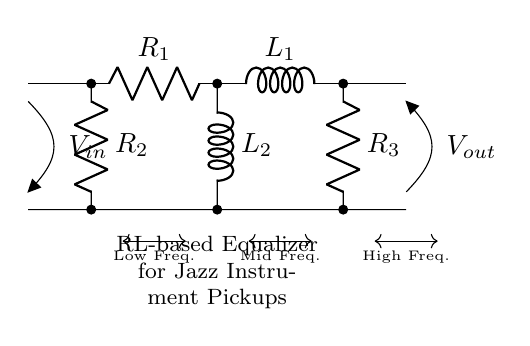What is the input voltage in this circuit? The input voltage is represented by V in the diagram, which is shown at the left side of the circuit. It is indicated as an open terminal labeled V in.
Answer: V in How many resistors are present in the circuit? The diagram shows three resistors designated as R one, R two, and R three, each labeled along the circuit. They are clearly identified by their respective symbols and labels.
Answer: 3 What type of inductors are used in this circuit? There are two inductors labeled as L one and L two in the diagram. Their labels indicate they are inductors, and they are connected in series with other components in the path of current.
Answer: 2 What is the function of the resistors in this circuit? The resistors are used to shape the frequency response of the circuit. In an RL-based circuit, resistors work together with inductors to control the gain and attenuation of different frequency ranges.
Answer: Shaping frequency response Which part of the circuit represents the low-frequency response? The section that includes R one and L one is designated for low frequency and is marked in the diagram below the circuit. This segment is the first in the chain, showing it processes lower frequencies primarily.
Answer: R one and L one What is the purpose of the labeled outputs in this circuit? The labeled output, V out, is the voltage across the output terminals of the circuit, indicating where the shaped signal can be observed or measured after processing through the R and L components.
Answer: Signal output What is the total number of components, including resistors and inductors, in the circuit? There are a total of five components: three resistors (R one, R two, R three) and two inductors (L one, L two). This count includes all active elements within the circuit diagram.
Answer: 5 